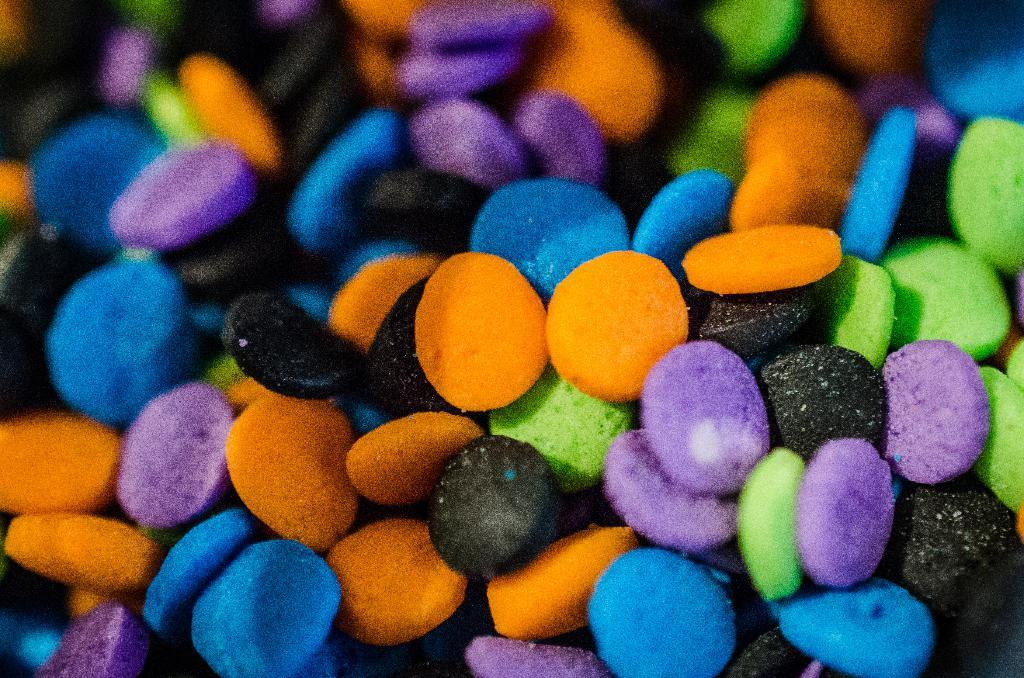What type of food is present in the image? There is candy in the image. What type of brick is being used to build the sofa in the image? There is no brick or sofa present in the image; it only features candy. 